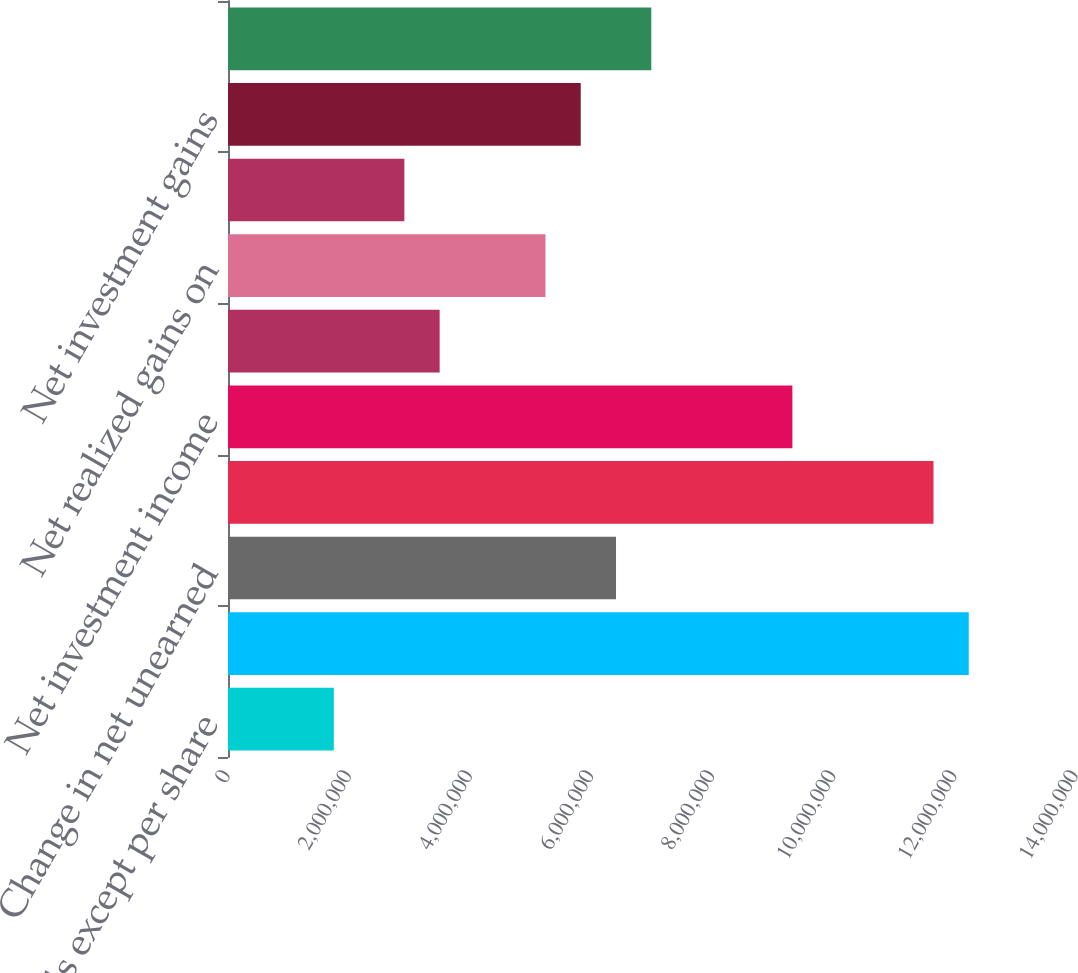Convert chart. <chart><loc_0><loc_0><loc_500><loc_500><bar_chart><fcel>(In thousands except per share<fcel>Net premiums written<fcel>Change in net unearned<fcel>Net premiums earned<fcel>Net investment income<fcel>Insurance service fees<fcel>Net realized gains on<fcel>Change in valuation allowance<fcel>Net investment gains<fcel>Revenues from wholly-owned<nl><fcel>1.74707e+06<fcel>1.22295e+07<fcel>6.40591e+06<fcel>1.16471e+07<fcel>9.31768e+06<fcel>3.49413e+06<fcel>5.2412e+06<fcel>2.91178e+06<fcel>5.82355e+06<fcel>6.98826e+06<nl></chart> 